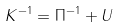<formula> <loc_0><loc_0><loc_500><loc_500>K ^ { - 1 } = \Pi ^ { - 1 } + U</formula> 